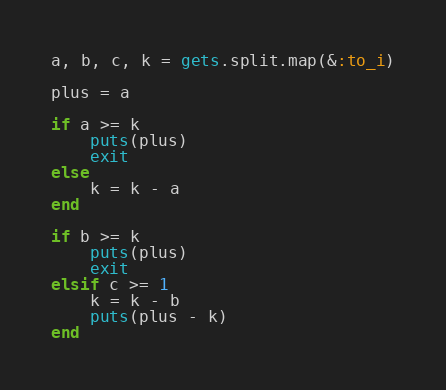<code> <loc_0><loc_0><loc_500><loc_500><_Ruby_>a, b, c, k = gets.split.map(&:to_i)

plus = a

if a >= k
    puts(plus)
    exit
else
    k = k - a
end

if b >= k
    puts(plus)
    exit
elsif c >= 1
    k = k - b
    puts(plus - k)
end</code> 